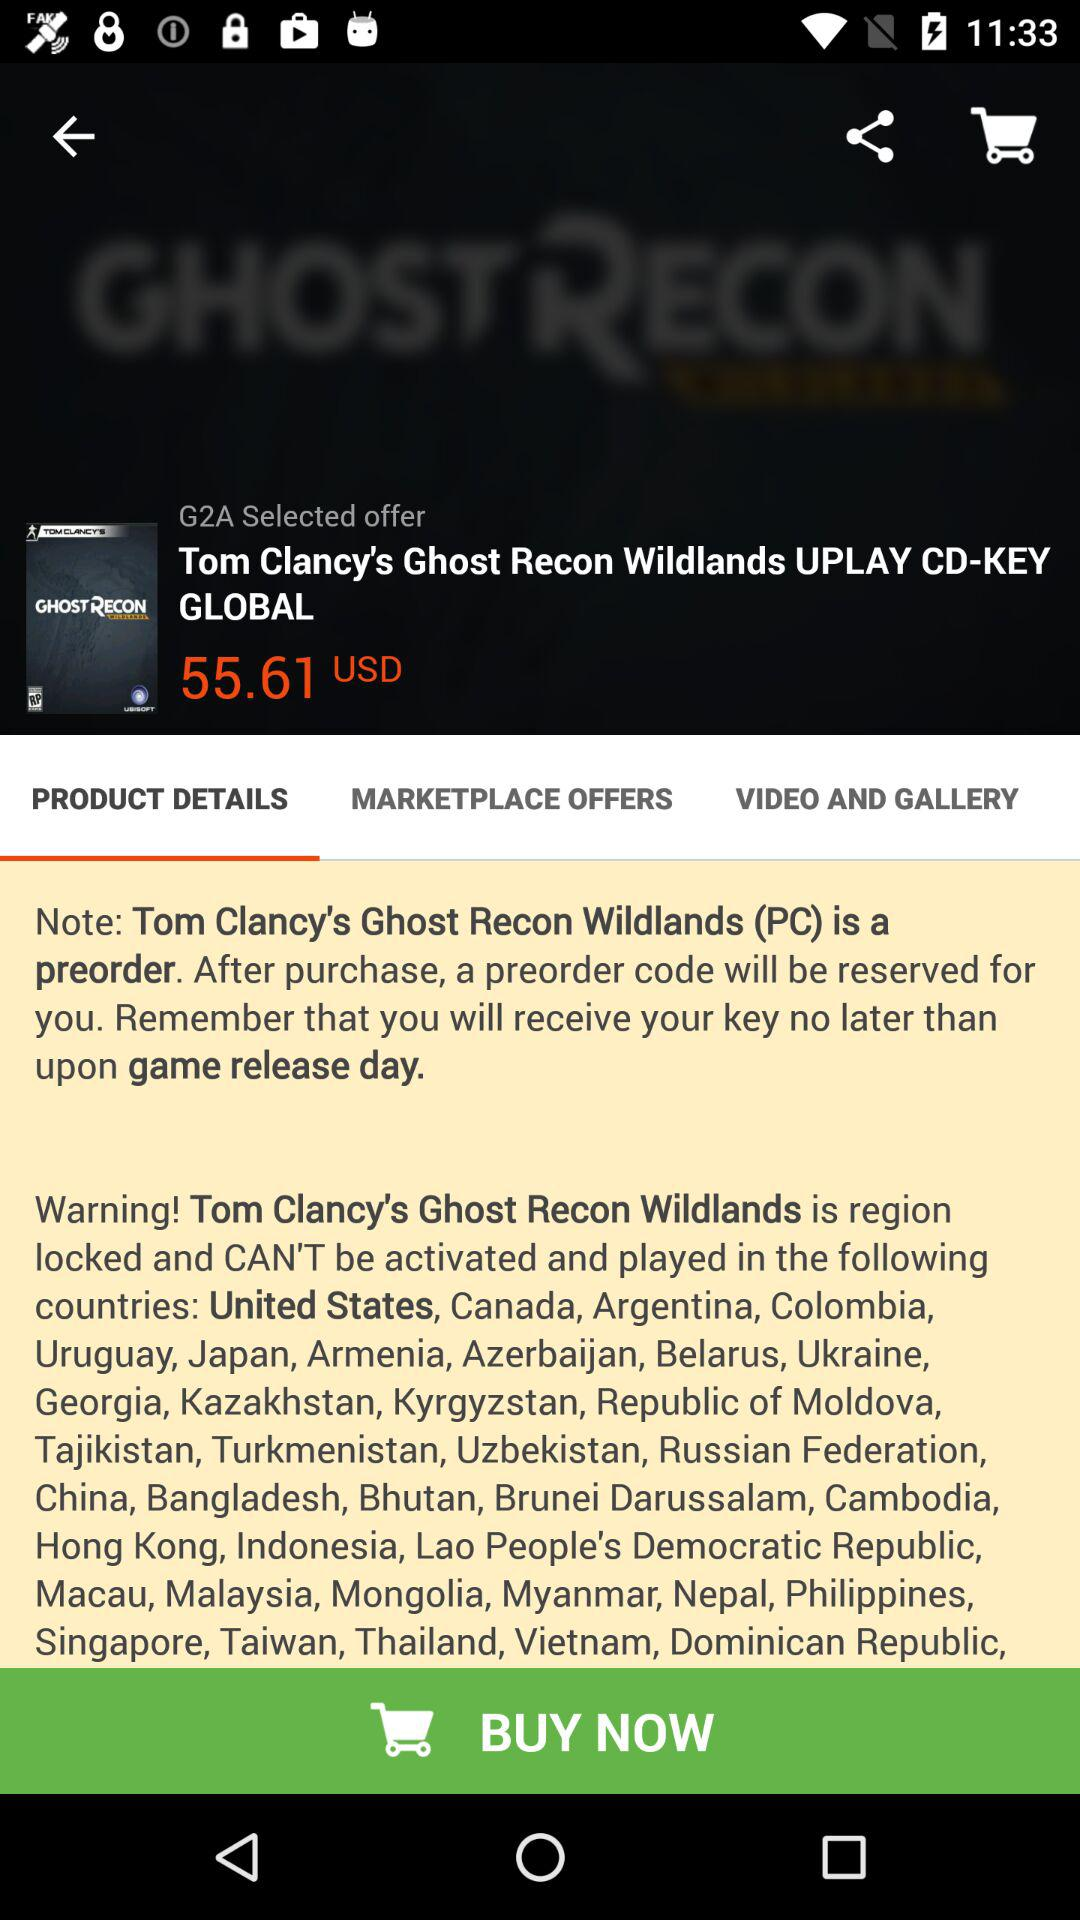Which tab is selected? The selected tab is "PRODUCT DETAILS". 